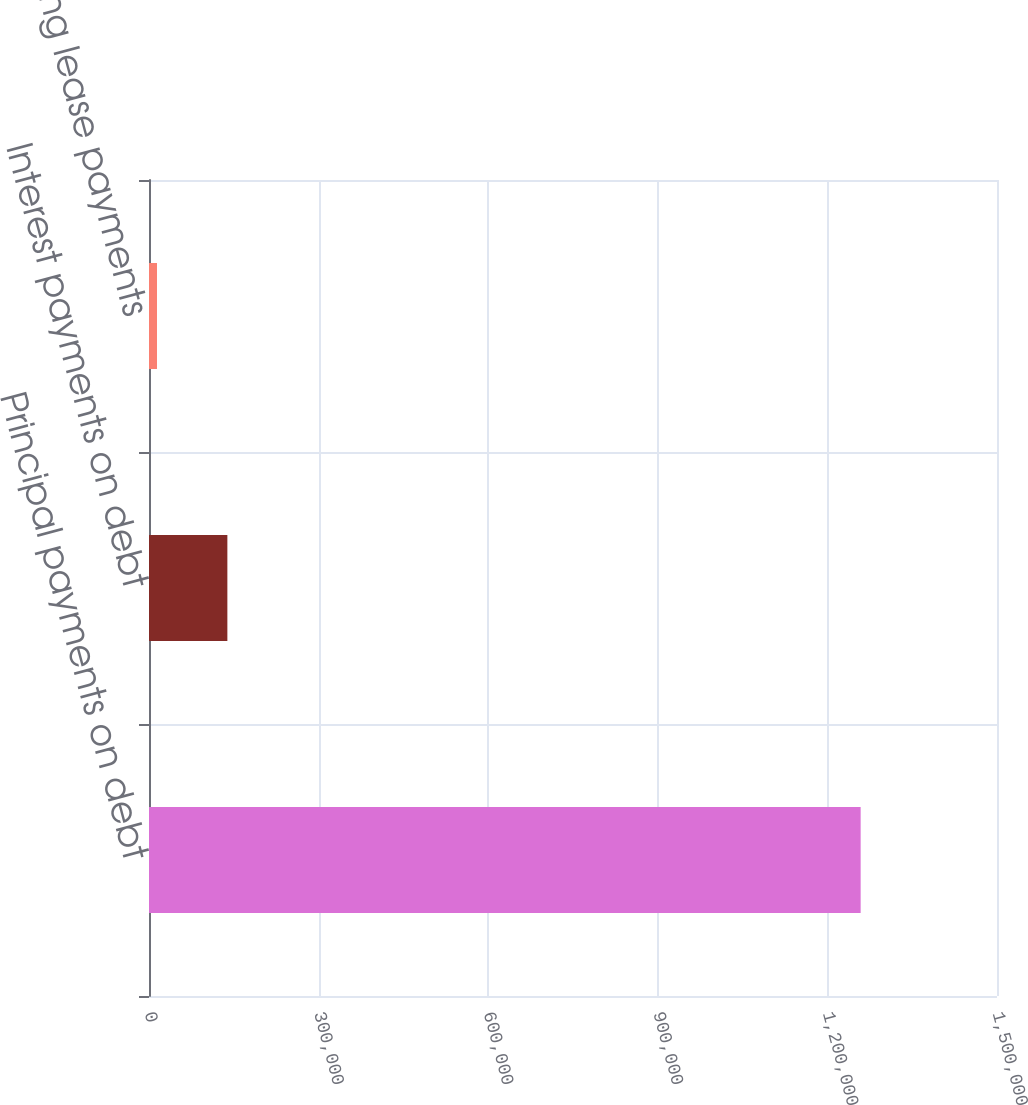Convert chart. <chart><loc_0><loc_0><loc_500><loc_500><bar_chart><fcel>Principal payments on debt<fcel>Interest payments on debt<fcel>Operating lease payments<nl><fcel>1.25881e+06<fcel>138617<fcel>14151<nl></chart> 